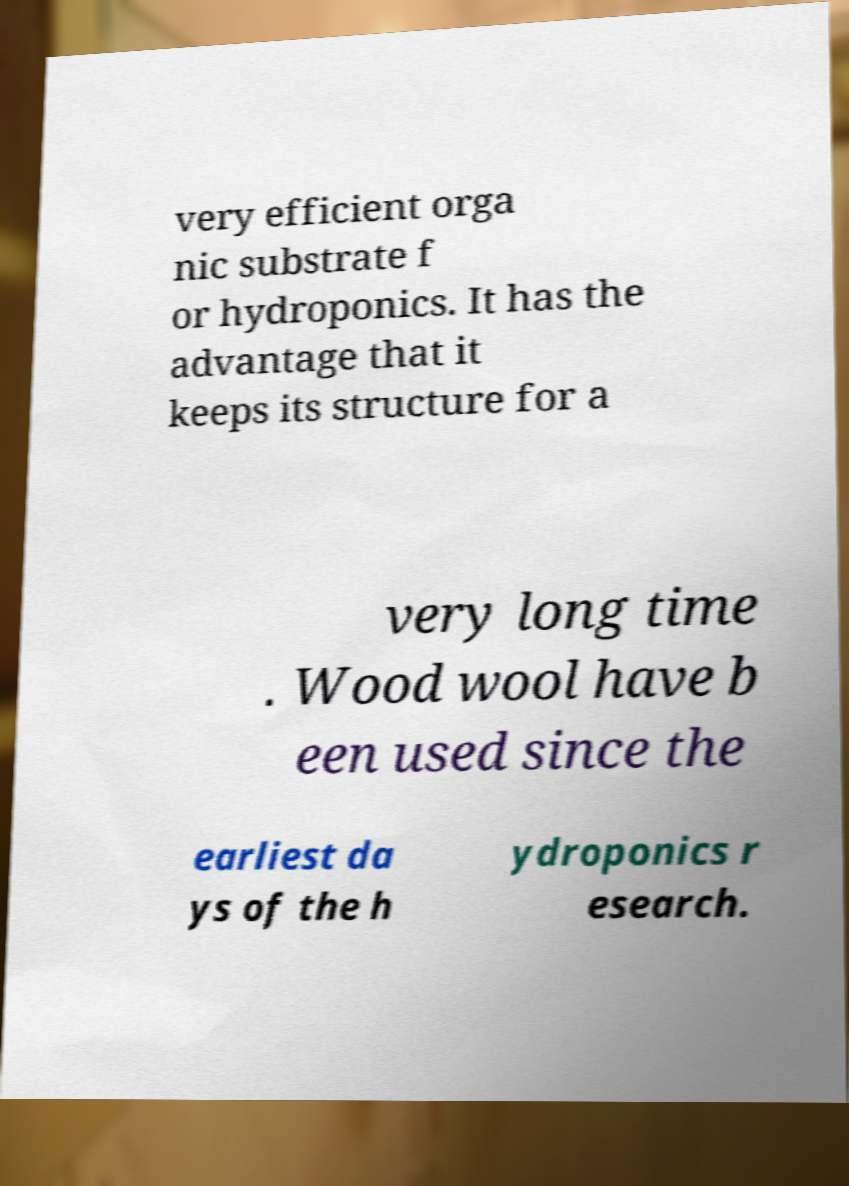Can you accurately transcribe the text from the provided image for me? very efficient orga nic substrate f or hydroponics. It has the advantage that it keeps its structure for a very long time . Wood wool have b een used since the earliest da ys of the h ydroponics r esearch. 